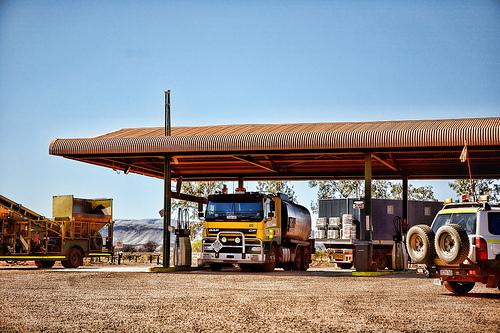Question: what kind of vehicle is in the middle of the picture?
Choices:
A. A truck.
B. A bus.
C. A train.
D. A taxi.
Answer with the letter. Answer: A Question: why are these trucks parked here?
Choices:
A. They are getting fuel.
B. They broke down.
C. The drivers are resting.
D. They are being repaired.
Answer with the letter. Answer: A Question: who drives these trucks?
Choices:
A. Truck drivers.
B. Men.
C. Women.
D. Anyone.
Answer with the letter. Answer: A Question: what is on the back of the truck on the right hand side of the photo?
Choices:
A. Two tires.
B. Boxes.
C. Crates.
D. Cars.
Answer with the letter. Answer: A 